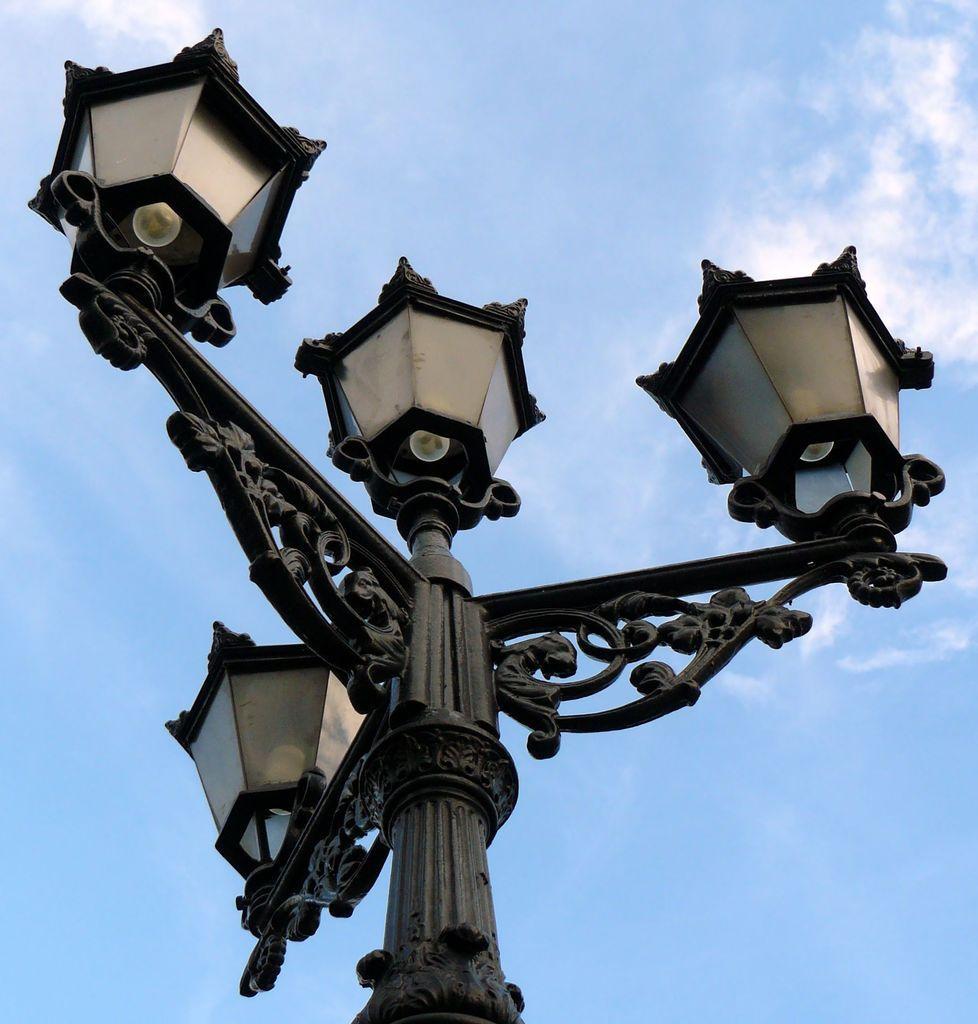How would you summarize this image in a sentence or two? In this picture, we see a pole and the street lights. It might be a lamp post. In the background, we see the clouds and the sky, which is blue in color. 